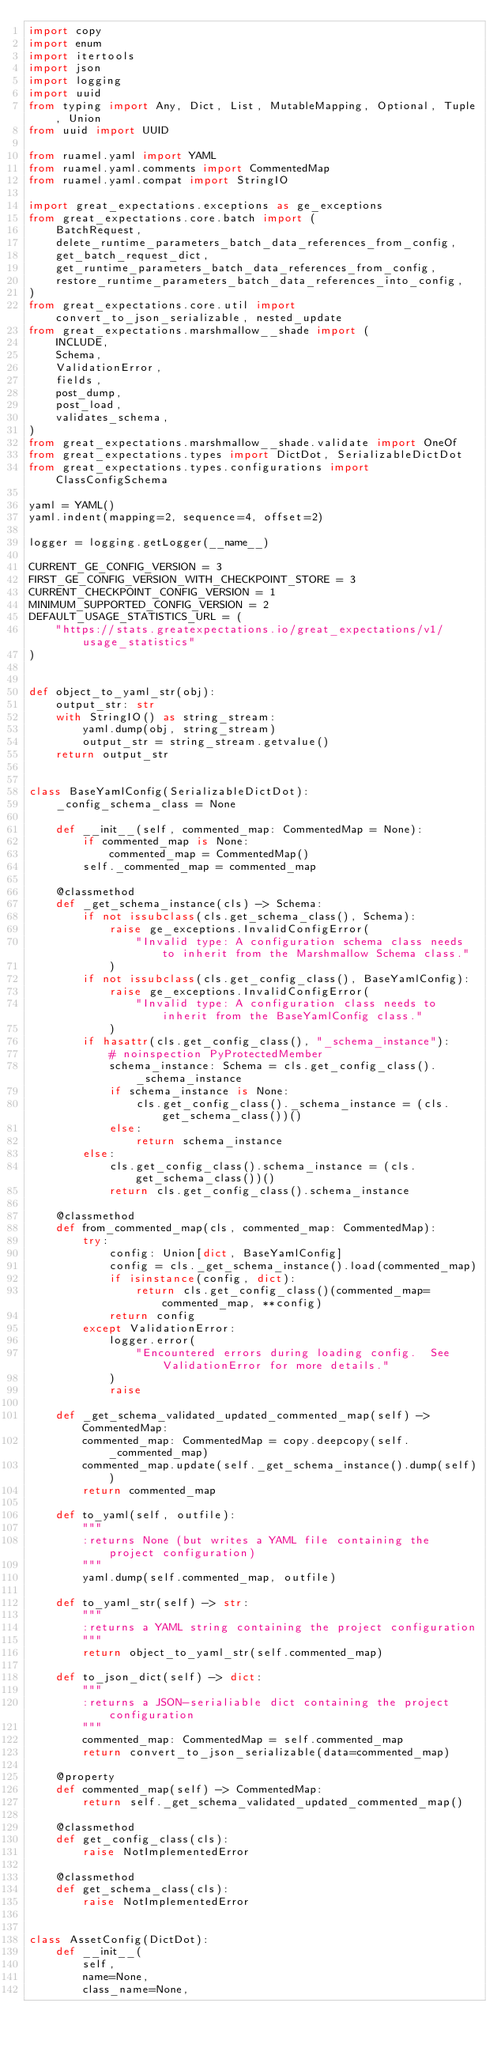Convert code to text. <code><loc_0><loc_0><loc_500><loc_500><_Python_>import copy
import enum
import itertools
import json
import logging
import uuid
from typing import Any, Dict, List, MutableMapping, Optional, Tuple, Union
from uuid import UUID

from ruamel.yaml import YAML
from ruamel.yaml.comments import CommentedMap
from ruamel.yaml.compat import StringIO

import great_expectations.exceptions as ge_exceptions
from great_expectations.core.batch import (
    BatchRequest,
    delete_runtime_parameters_batch_data_references_from_config,
    get_batch_request_dict,
    get_runtime_parameters_batch_data_references_from_config,
    restore_runtime_parameters_batch_data_references_into_config,
)
from great_expectations.core.util import convert_to_json_serializable, nested_update
from great_expectations.marshmallow__shade import (
    INCLUDE,
    Schema,
    ValidationError,
    fields,
    post_dump,
    post_load,
    validates_schema,
)
from great_expectations.marshmallow__shade.validate import OneOf
from great_expectations.types import DictDot, SerializableDictDot
from great_expectations.types.configurations import ClassConfigSchema

yaml = YAML()
yaml.indent(mapping=2, sequence=4, offset=2)

logger = logging.getLogger(__name__)

CURRENT_GE_CONFIG_VERSION = 3
FIRST_GE_CONFIG_VERSION_WITH_CHECKPOINT_STORE = 3
CURRENT_CHECKPOINT_CONFIG_VERSION = 1
MINIMUM_SUPPORTED_CONFIG_VERSION = 2
DEFAULT_USAGE_STATISTICS_URL = (
    "https://stats.greatexpectations.io/great_expectations/v1/usage_statistics"
)


def object_to_yaml_str(obj):
    output_str: str
    with StringIO() as string_stream:
        yaml.dump(obj, string_stream)
        output_str = string_stream.getvalue()
    return output_str


class BaseYamlConfig(SerializableDictDot):
    _config_schema_class = None

    def __init__(self, commented_map: CommentedMap = None):
        if commented_map is None:
            commented_map = CommentedMap()
        self._commented_map = commented_map

    @classmethod
    def _get_schema_instance(cls) -> Schema:
        if not issubclass(cls.get_schema_class(), Schema):
            raise ge_exceptions.InvalidConfigError(
                "Invalid type: A configuration schema class needs to inherit from the Marshmallow Schema class."
            )
        if not issubclass(cls.get_config_class(), BaseYamlConfig):
            raise ge_exceptions.InvalidConfigError(
                "Invalid type: A configuration class needs to inherit from the BaseYamlConfig class."
            )
        if hasattr(cls.get_config_class(), "_schema_instance"):
            # noinspection PyProtectedMember
            schema_instance: Schema = cls.get_config_class()._schema_instance
            if schema_instance is None:
                cls.get_config_class()._schema_instance = (cls.get_schema_class())()
            else:
                return schema_instance
        else:
            cls.get_config_class().schema_instance = (cls.get_schema_class())()
            return cls.get_config_class().schema_instance

    @classmethod
    def from_commented_map(cls, commented_map: CommentedMap):
        try:
            config: Union[dict, BaseYamlConfig]
            config = cls._get_schema_instance().load(commented_map)
            if isinstance(config, dict):
                return cls.get_config_class()(commented_map=commented_map, **config)
            return config
        except ValidationError:
            logger.error(
                "Encountered errors during loading config.  See ValidationError for more details."
            )
            raise

    def _get_schema_validated_updated_commented_map(self) -> CommentedMap:
        commented_map: CommentedMap = copy.deepcopy(self._commented_map)
        commented_map.update(self._get_schema_instance().dump(self))
        return commented_map

    def to_yaml(self, outfile):
        """
        :returns None (but writes a YAML file containing the project configuration)
        """
        yaml.dump(self.commented_map, outfile)

    def to_yaml_str(self) -> str:
        """
        :returns a YAML string containing the project configuration
        """
        return object_to_yaml_str(self.commented_map)

    def to_json_dict(self) -> dict:
        """
        :returns a JSON-serialiable dict containing the project configuration
        """
        commented_map: CommentedMap = self.commented_map
        return convert_to_json_serializable(data=commented_map)

    @property
    def commented_map(self) -> CommentedMap:
        return self._get_schema_validated_updated_commented_map()

    @classmethod
    def get_config_class(cls):
        raise NotImplementedError

    @classmethod
    def get_schema_class(cls):
        raise NotImplementedError


class AssetConfig(DictDot):
    def __init__(
        self,
        name=None,
        class_name=None,</code> 